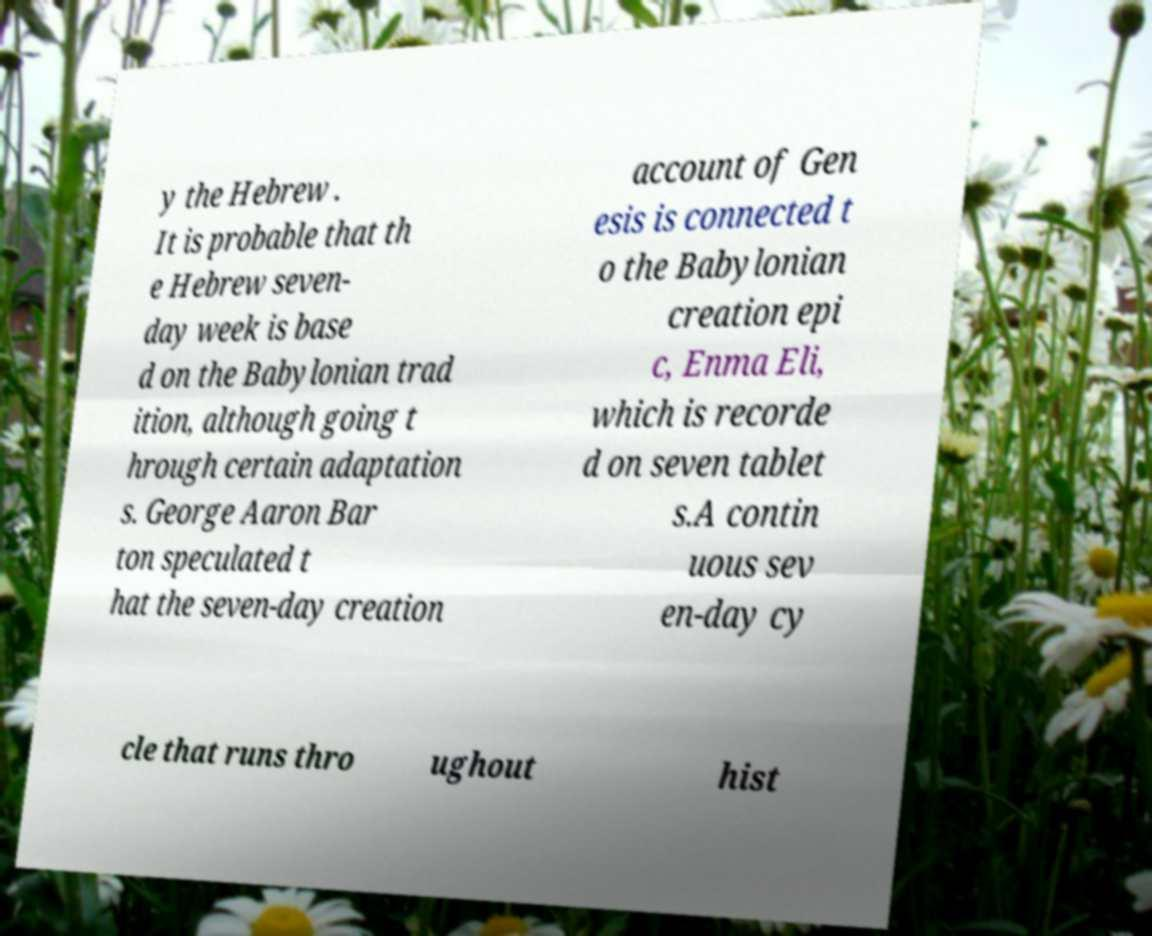I need the written content from this picture converted into text. Can you do that? y the Hebrew . It is probable that th e Hebrew seven- day week is base d on the Babylonian trad ition, although going t hrough certain adaptation s. George Aaron Bar ton speculated t hat the seven-day creation account of Gen esis is connected t o the Babylonian creation epi c, Enma Eli, which is recorde d on seven tablet s.A contin uous sev en-day cy cle that runs thro ughout hist 